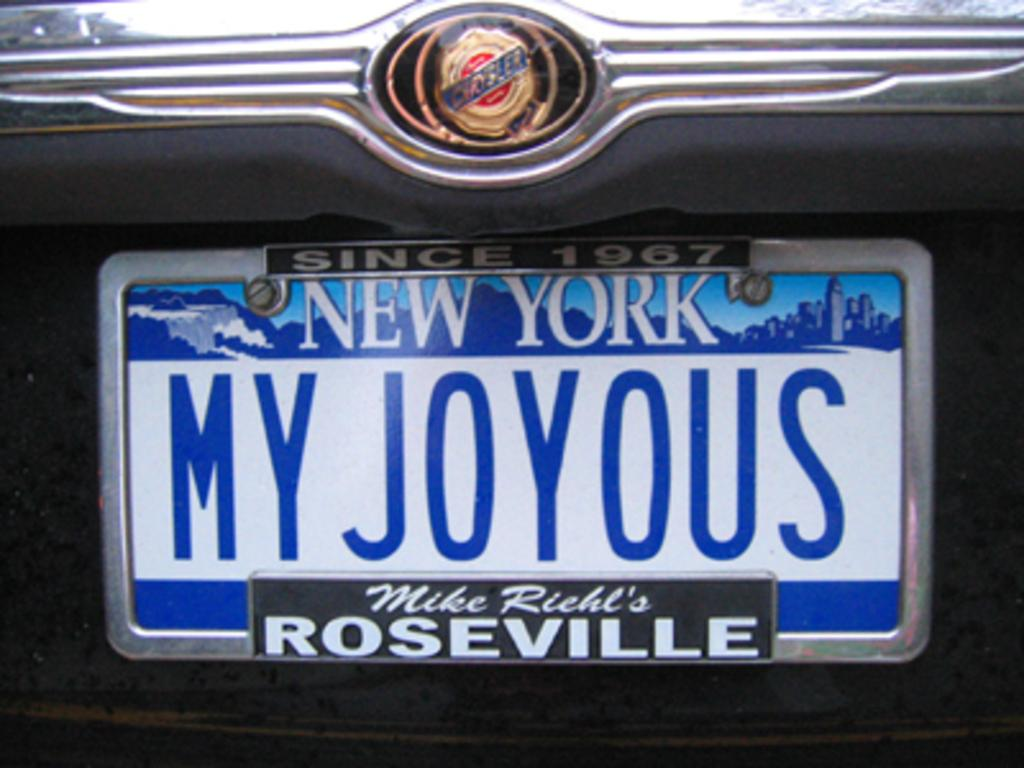<image>
Present a compact description of the photo's key features. Blue and white New York license plate which says MY JOYOUS. 